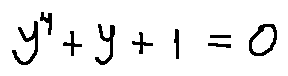Convert formula to latex. <formula><loc_0><loc_0><loc_500><loc_500>y ^ { 4 } + y + 1 = 0</formula> 